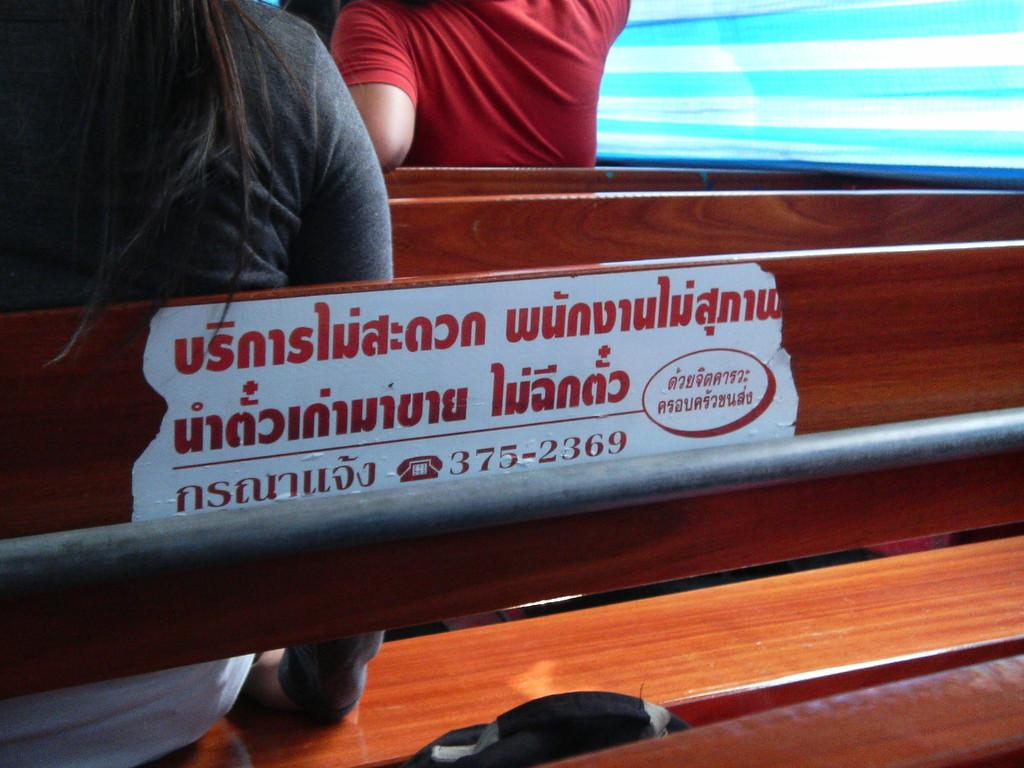What are the people in the image doing? The people in the image are seated on benches. Can you describe any objects in the image besides the benches? Yes, there is a metal rod in the image. What type of prose is being read by the people seated on the benches in the image? There is no indication in the image that the people are reading any prose, as the focus is on their seating position and the presence of a metal rod. 